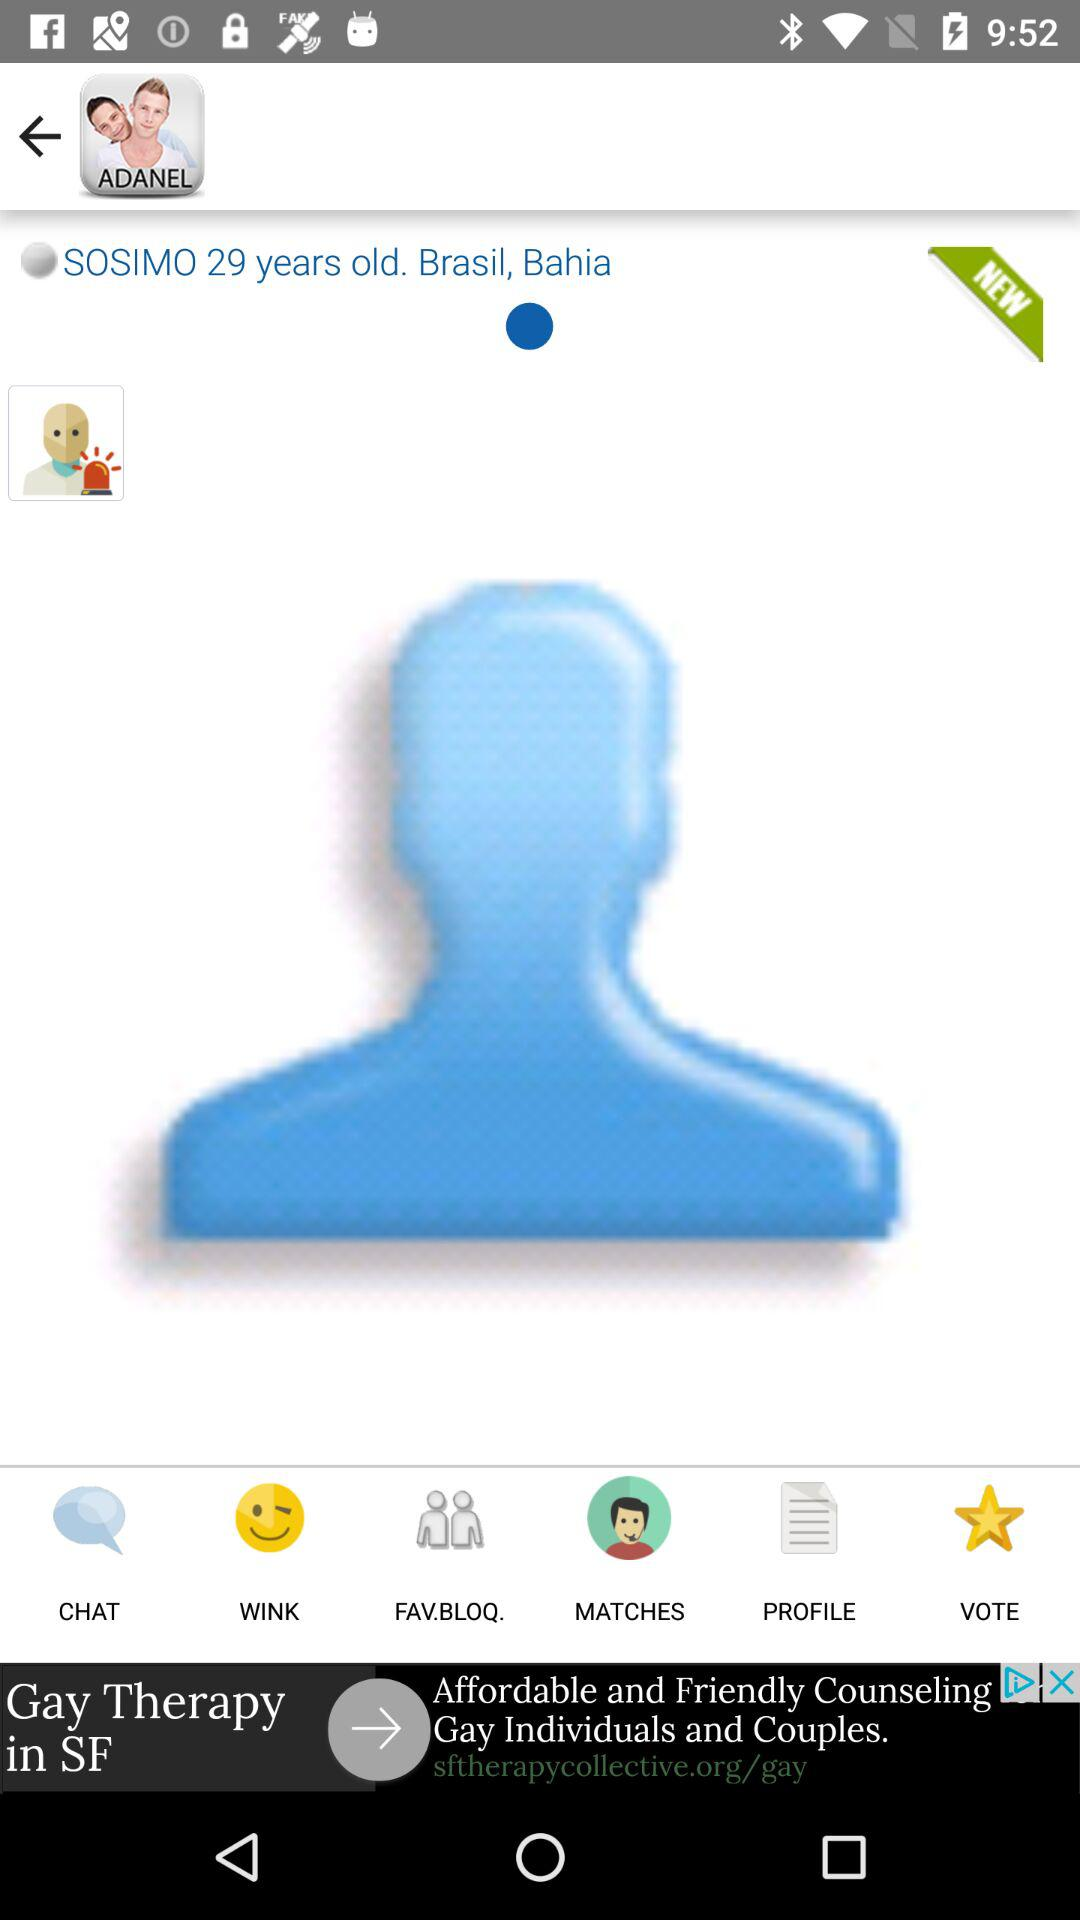What is the age? The age is 29 years. 